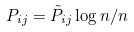<formula> <loc_0><loc_0><loc_500><loc_500>P _ { i j } = \tilde { P } _ { i j } \log n / n</formula> 